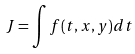<formula> <loc_0><loc_0><loc_500><loc_500>J = \int f ( t , x , y ) d t</formula> 